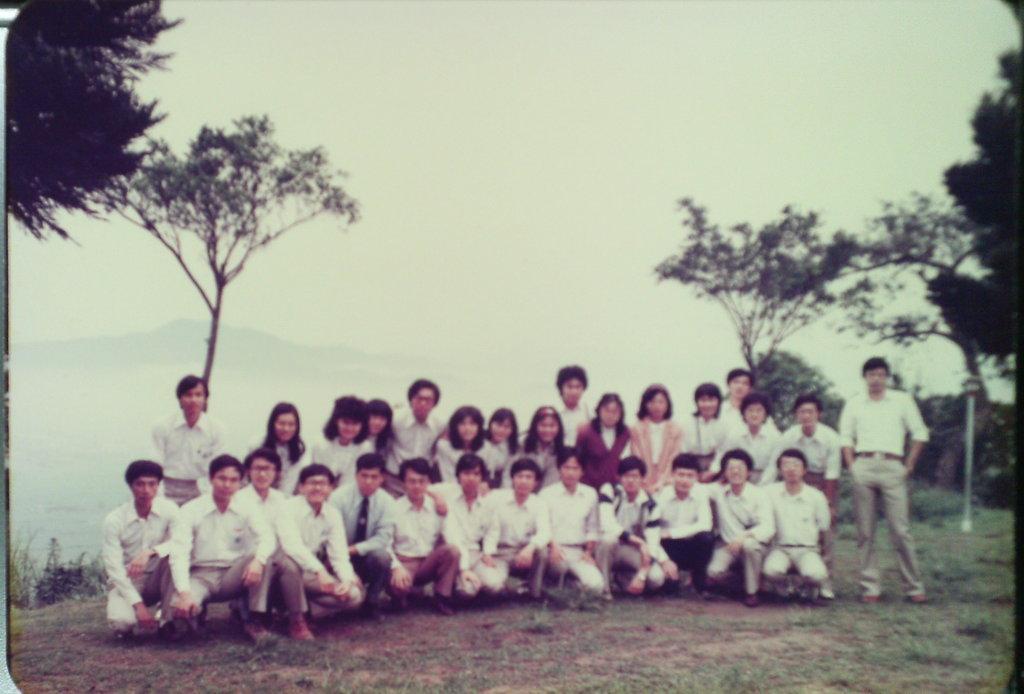How would you summarize this image in a sentence or two? In this picture there are boys and girls those who are sitting in the center of the image and there is greenery in the image. 